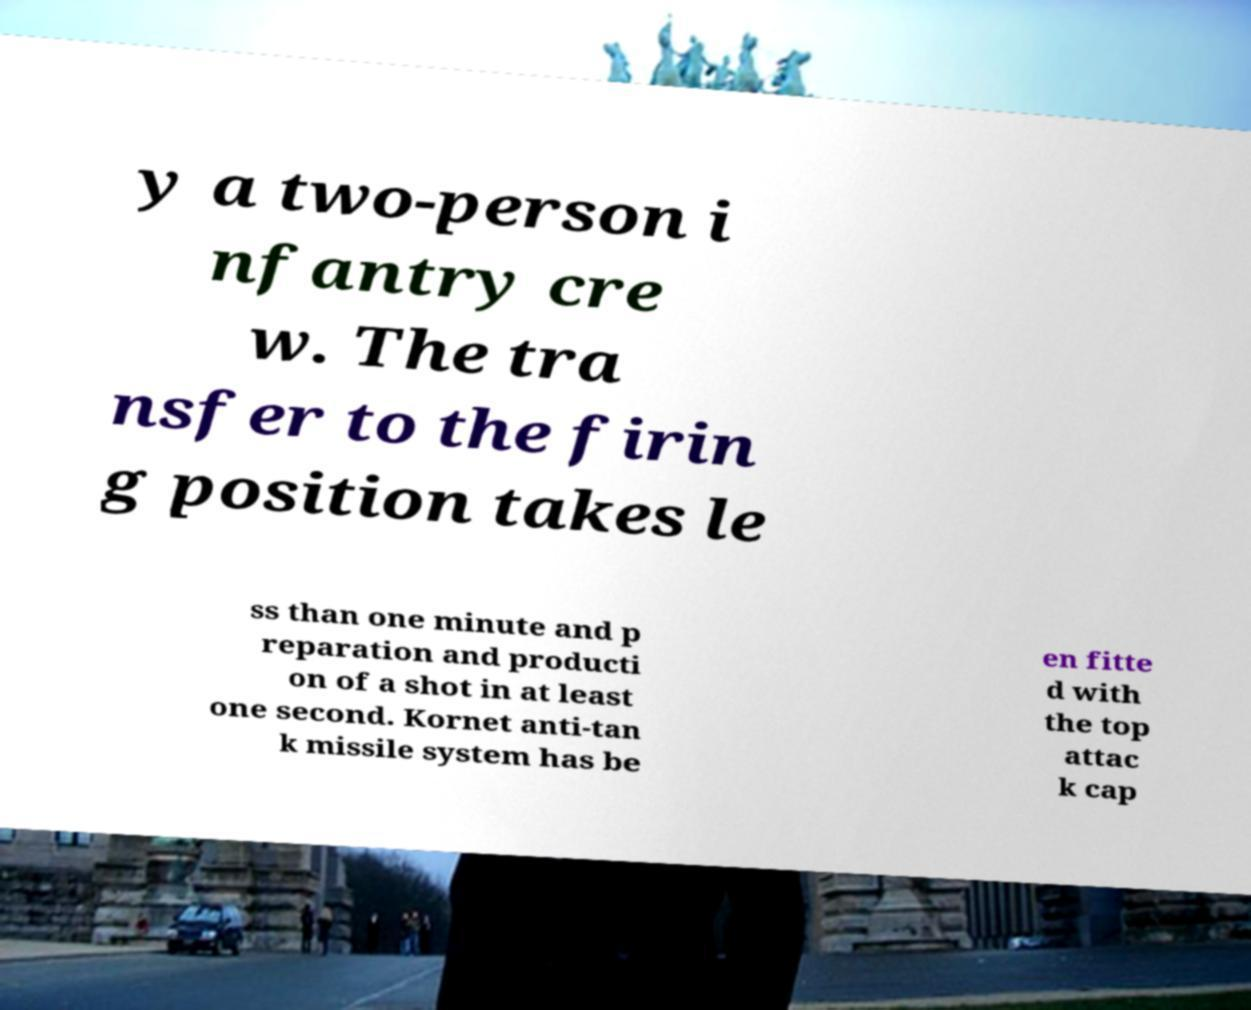What messages or text are displayed in this image? I need them in a readable, typed format. y a two-person i nfantry cre w. The tra nsfer to the firin g position takes le ss than one minute and p reparation and producti on of a shot in at least one second. Kornet anti-tan k missile system has be en fitte d with the top attac k cap 